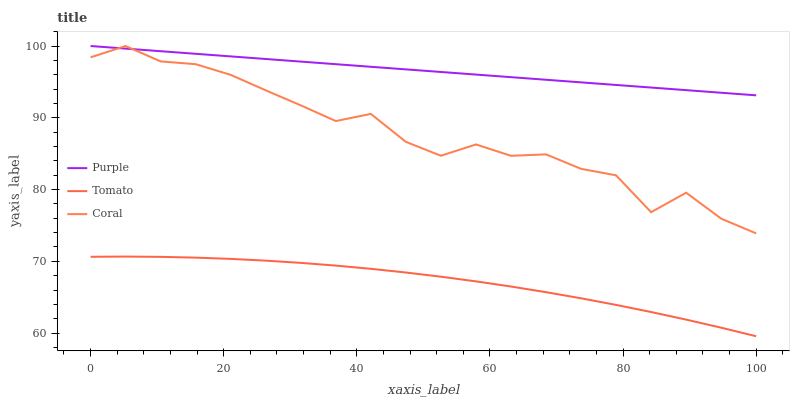Does Tomato have the minimum area under the curve?
Answer yes or no. Yes. Does Purple have the maximum area under the curve?
Answer yes or no. Yes. Does Coral have the minimum area under the curve?
Answer yes or no. No. Does Coral have the maximum area under the curve?
Answer yes or no. No. Is Purple the smoothest?
Answer yes or no. Yes. Is Coral the roughest?
Answer yes or no. Yes. Is Tomato the smoothest?
Answer yes or no. No. Is Tomato the roughest?
Answer yes or no. No. Does Tomato have the lowest value?
Answer yes or no. Yes. Does Coral have the lowest value?
Answer yes or no. No. Does Coral have the highest value?
Answer yes or no. Yes. Does Tomato have the highest value?
Answer yes or no. No. Is Tomato less than Purple?
Answer yes or no. Yes. Is Coral greater than Tomato?
Answer yes or no. Yes. Does Purple intersect Coral?
Answer yes or no. Yes. Is Purple less than Coral?
Answer yes or no. No. Is Purple greater than Coral?
Answer yes or no. No. Does Tomato intersect Purple?
Answer yes or no. No. 